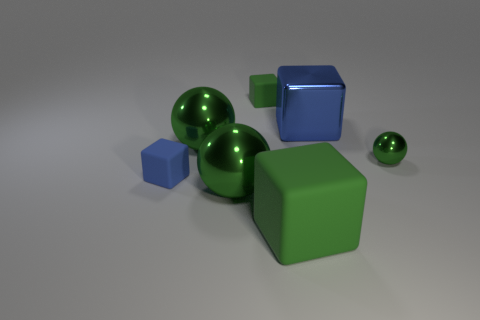How many cylinders are either small green rubber objects or small things?
Offer a terse response. 0. There is another tiny block that is the same material as the tiny blue cube; what color is it?
Ensure brevity in your answer.  Green. Do the metal object on the right side of the metal block and the large blue metal thing have the same size?
Your answer should be very brief. No. Do the tiny blue thing and the green cube that is in front of the tiny blue block have the same material?
Make the answer very short. Yes. What color is the small rubber object behind the small green metal object?
Your answer should be compact. Green. There is a green block that is behind the metallic cube; is there a large thing that is in front of it?
Offer a terse response. Yes. There is a shiny block that is on the left side of the tiny green sphere; does it have the same color as the tiny matte thing in front of the small green matte object?
Make the answer very short. Yes. How many tiny objects are on the left side of the tiny metal thing?
Provide a short and direct response. 2. What number of other metallic balls have the same color as the tiny sphere?
Provide a short and direct response. 2. Is the blue block that is behind the blue matte cube made of the same material as the small green cube?
Provide a short and direct response. No. 